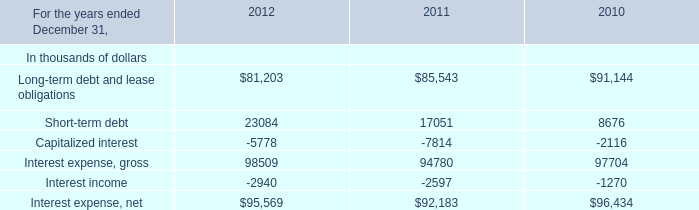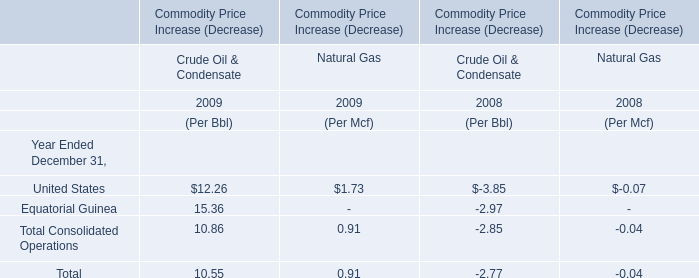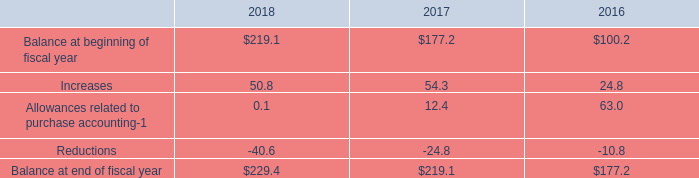in 2018 what was the percentage change in the valuation allowances against deferred tax assets 
Computations: ((229.4 - 219.1) / 219.1)
Answer: 0.04701. 